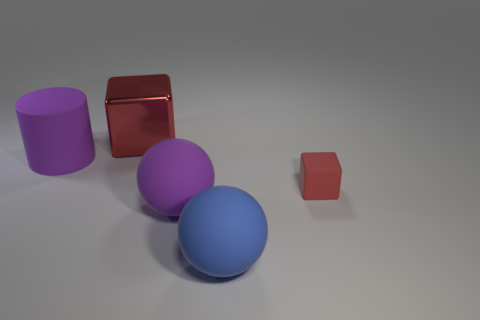What number of other things are there of the same color as the big cylinder?
Keep it short and to the point. 1. What number of other big objects have the same shape as the big red metallic thing?
Give a very brief answer. 0. What size is the cube that is made of the same material as the cylinder?
Keep it short and to the point. Small. There is a object that is both to the right of the purple rubber cylinder and behind the tiny red cube; what material is it made of?
Give a very brief answer. Metal. How many blue matte things have the same size as the shiny object?
Make the answer very short. 1. There is another big object that is the same shape as the big blue rubber thing; what is it made of?
Your answer should be compact. Rubber. How many objects are either purple objects that are behind the small red block or objects in front of the purple cylinder?
Provide a succinct answer. 4. There is a big red metallic thing; does it have the same shape as the big purple thing to the left of the large red metal thing?
Your answer should be very brief. No. What is the shape of the object behind the cylinder that is to the left of the object that is behind the big cylinder?
Your answer should be compact. Cube. How many other things are there of the same material as the small red object?
Your answer should be very brief. 3. 